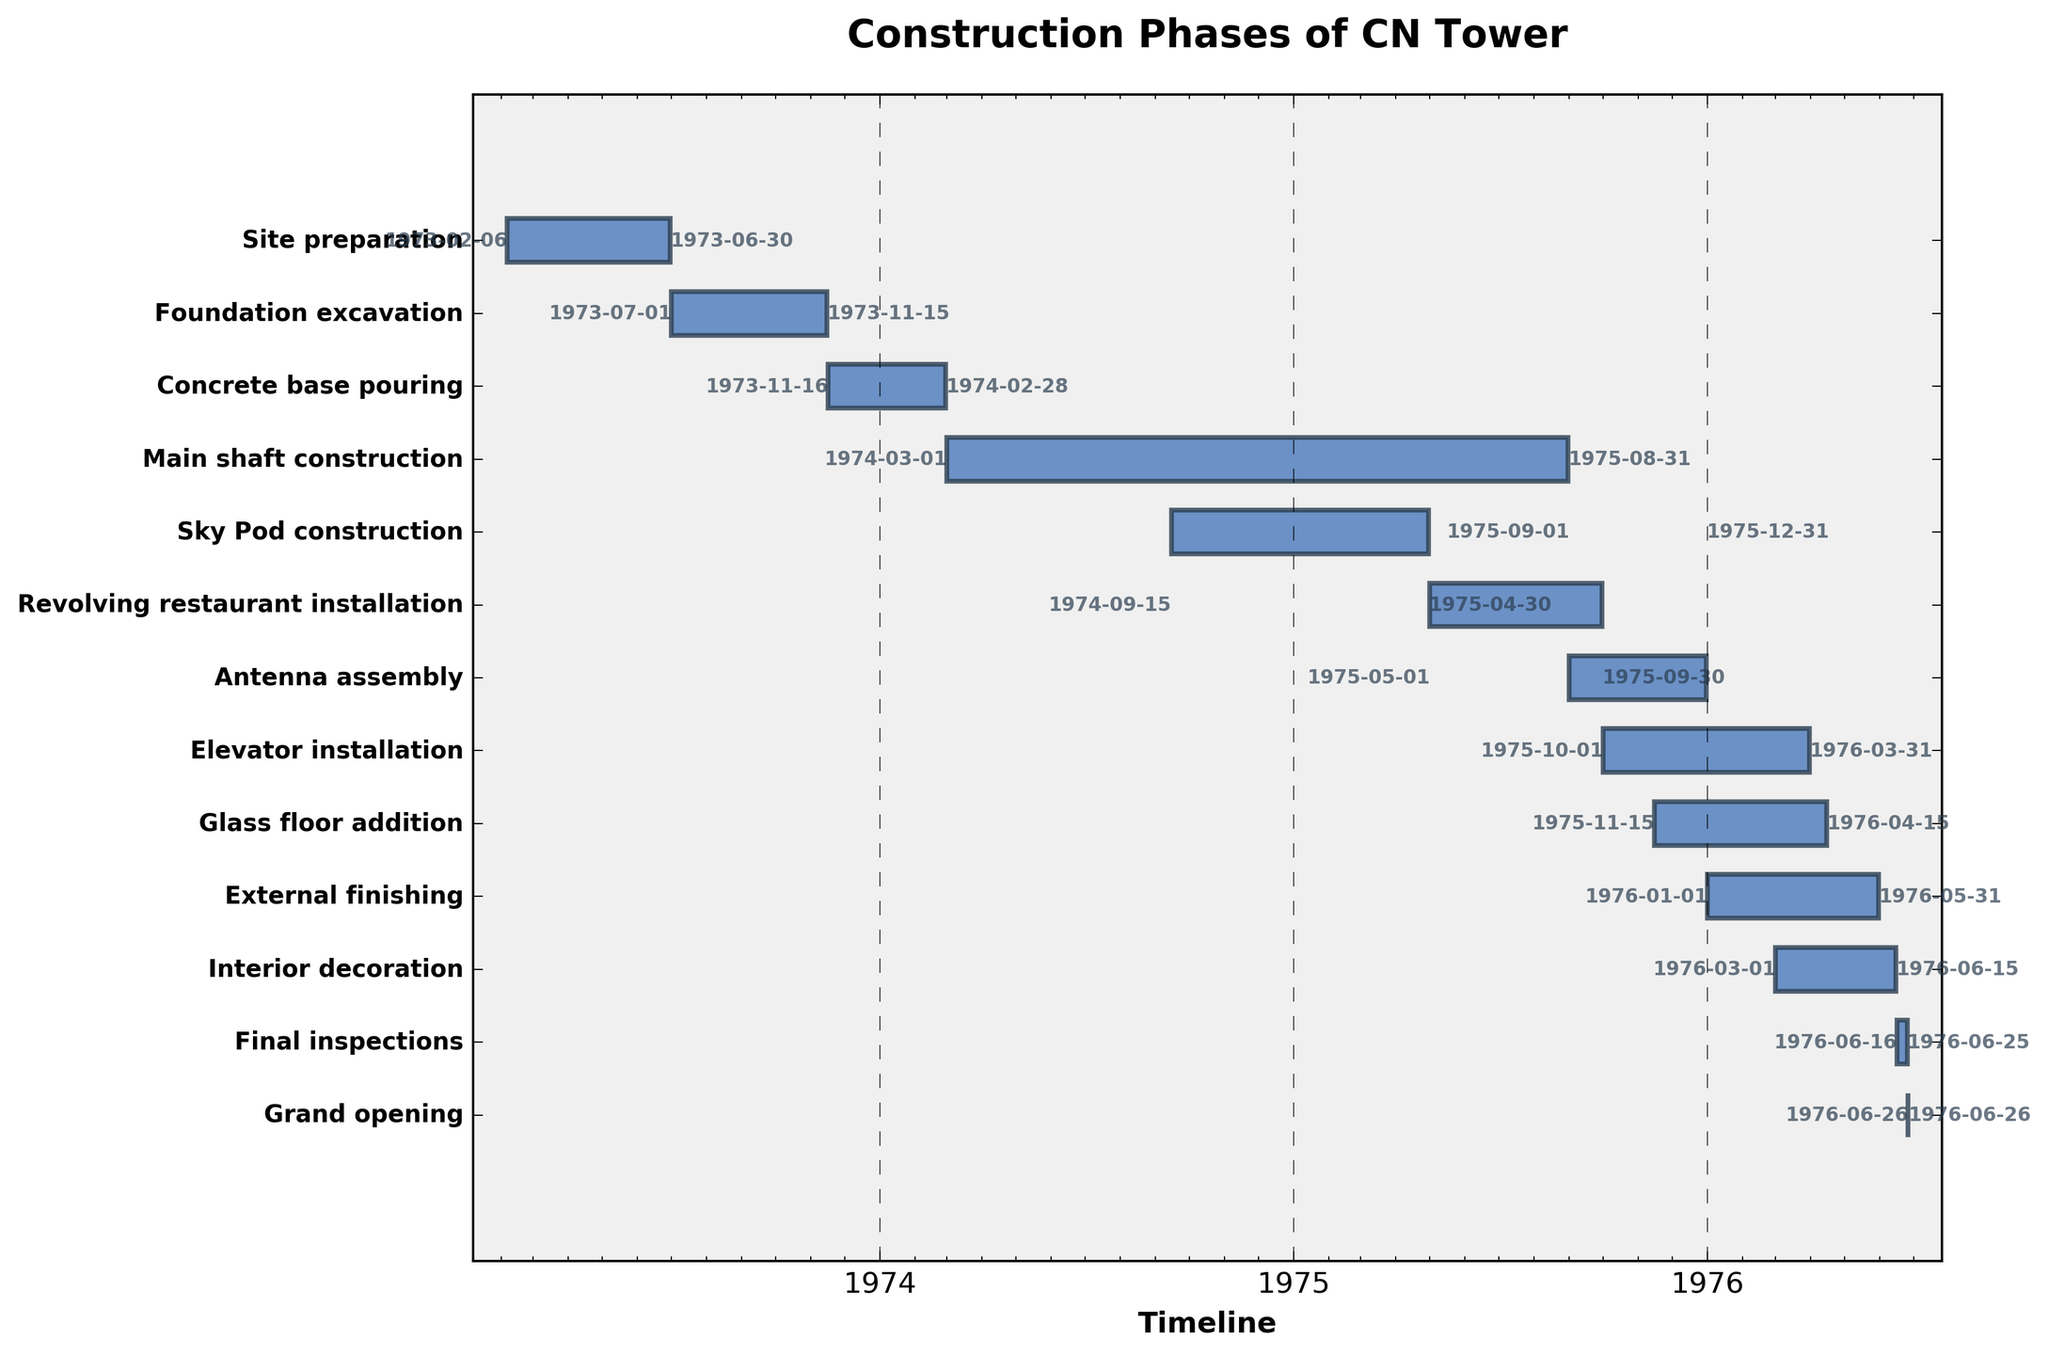What is the title of the Gantt chart? The title of the Gantt chart can usually be found at the top of the figure. In this chart, it is "Construction Phases of CN Tower".
Answer: Construction Phases of CN Tower How many construction tasks are shown in the chart? The y-axis labels each task involved in the construction, and by counting these labels, we can determine the number of tasks.
Answer: 12 What task had the earliest start date and what was that date? To find the earliest start date, identify the task that begins first on the timeline. "Site preparation" is the first task with the start date 1973-02-06.
Answer: Site preparation, 1973-02-06 Which task took the longest time to complete and how long did it take? Compare the duration of each task, which is indicated by the length of the bars. "Main shaft construction" took the longest with a duration from 1974-03-01 to 1975-08-31, which is approximately 18 months.
Answer: Main shaft construction, approximately 18 months How many tasks were still ongoing at the end of 1975? Look at tasks that have an end date later than 1975-12-31. The ongoing tasks at that time are "Elevator installation", "Glass floor addition", "External finishing", and "Interior decoration".
Answer: 4 Which two tasks had overlapping timelines starting around March 1974? Review the tasks that commence around March 1974. "Main shaft construction" started on 1974-03-01, and "Sky Pod construction" started on 1974-09-15. These tasks overlapped from September 1974.
Answer: Main shaft construction and Sky Pod construction When did the "Revolving restaurant installation" begin and end? Locate "Revolving restaurant installation" on the y-axis and read the start and end dates from the visual representation of the bars. It began on 1975-05-01 and ended on 1975-09-30.
Answer: 1975-05-01 to 1975-09-30 Which task was the last to be completed before the grand opening? Look at the task that finishes closest to the "Grand opening" date of 1976-06-26. "Final inspections" was completed on 1976-06-25.
Answer: Final inspections List the tasks that started in 1975. Identify tasks with a start date in the year 1975. These tasks are "Antenna assembly", "Revolving restaurant installation", "Glass floor addition", and "Elevator installation".
Answer: Antenna assembly, Revolving restaurant installation, Glass floor addition, Elevator installation Which task ended the latest and when did it end? To find the latest end date, review the end dates of all tasks. The task "Interior decoration" ended the latest on 1976-06-15.
Answer: Interior decoration, 1976-06-15 